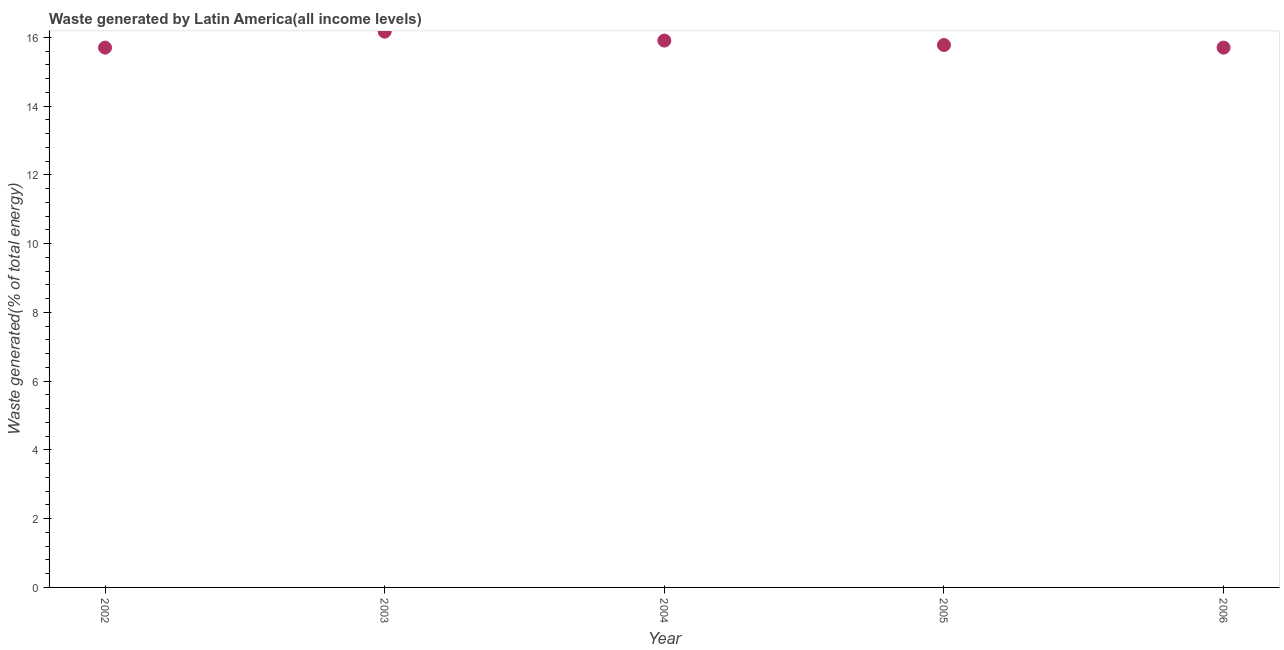What is the amount of waste generated in 2004?
Offer a very short reply. 15.91. Across all years, what is the maximum amount of waste generated?
Provide a succinct answer. 16.17. Across all years, what is the minimum amount of waste generated?
Make the answer very short. 15.7. In which year was the amount of waste generated minimum?
Your answer should be compact. 2006. What is the sum of the amount of waste generated?
Keep it short and to the point. 79.25. What is the difference between the amount of waste generated in 2005 and 2006?
Provide a succinct answer. 0.08. What is the average amount of waste generated per year?
Your answer should be very brief. 15.85. What is the median amount of waste generated?
Provide a short and direct response. 15.78. Do a majority of the years between 2004 and 2003 (inclusive) have amount of waste generated greater than 7.2 %?
Keep it short and to the point. No. What is the ratio of the amount of waste generated in 2003 to that in 2004?
Offer a terse response. 1.02. Is the amount of waste generated in 2003 less than that in 2004?
Offer a very short reply. No. Is the difference between the amount of waste generated in 2002 and 2003 greater than the difference between any two years?
Provide a short and direct response. No. What is the difference between the highest and the second highest amount of waste generated?
Your response must be concise. 0.26. What is the difference between the highest and the lowest amount of waste generated?
Your answer should be compact. 0.47. In how many years, is the amount of waste generated greater than the average amount of waste generated taken over all years?
Your answer should be very brief. 2. How many dotlines are there?
Make the answer very short. 1. How many years are there in the graph?
Give a very brief answer. 5. Are the values on the major ticks of Y-axis written in scientific E-notation?
Offer a terse response. No. Does the graph contain grids?
Ensure brevity in your answer.  No. What is the title of the graph?
Provide a short and direct response. Waste generated by Latin America(all income levels). What is the label or title of the Y-axis?
Ensure brevity in your answer.  Waste generated(% of total energy). What is the Waste generated(% of total energy) in 2002?
Your response must be concise. 15.7. What is the Waste generated(% of total energy) in 2003?
Your answer should be compact. 16.17. What is the Waste generated(% of total energy) in 2004?
Your answer should be very brief. 15.91. What is the Waste generated(% of total energy) in 2005?
Give a very brief answer. 15.78. What is the Waste generated(% of total energy) in 2006?
Ensure brevity in your answer.  15.7. What is the difference between the Waste generated(% of total energy) in 2002 and 2003?
Keep it short and to the point. -0.47. What is the difference between the Waste generated(% of total energy) in 2002 and 2004?
Your answer should be compact. -0.2. What is the difference between the Waste generated(% of total energy) in 2002 and 2005?
Keep it short and to the point. -0.08. What is the difference between the Waste generated(% of total energy) in 2002 and 2006?
Provide a short and direct response. 0. What is the difference between the Waste generated(% of total energy) in 2003 and 2004?
Offer a terse response. 0.26. What is the difference between the Waste generated(% of total energy) in 2003 and 2005?
Offer a very short reply. 0.39. What is the difference between the Waste generated(% of total energy) in 2003 and 2006?
Offer a terse response. 0.47. What is the difference between the Waste generated(% of total energy) in 2004 and 2005?
Give a very brief answer. 0.13. What is the difference between the Waste generated(% of total energy) in 2004 and 2006?
Offer a very short reply. 0.21. What is the difference between the Waste generated(% of total energy) in 2005 and 2006?
Offer a terse response. 0.08. What is the ratio of the Waste generated(% of total energy) in 2002 to that in 2004?
Offer a very short reply. 0.99. What is the ratio of the Waste generated(% of total energy) in 2003 to that in 2004?
Your answer should be compact. 1.02. What is the ratio of the Waste generated(% of total energy) in 2003 to that in 2006?
Provide a short and direct response. 1.03. What is the ratio of the Waste generated(% of total energy) in 2005 to that in 2006?
Your answer should be compact. 1. 